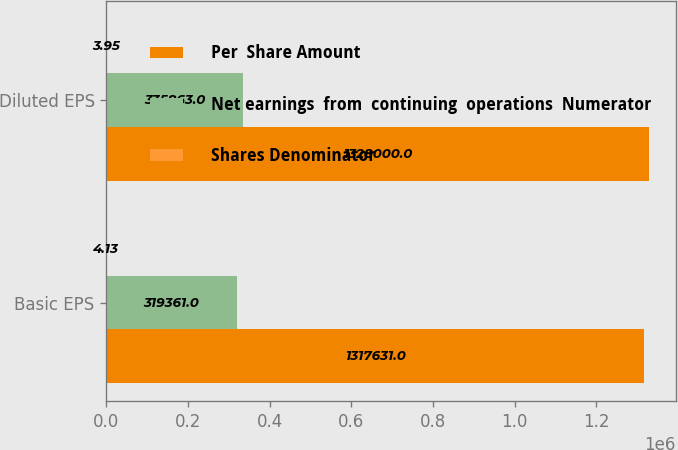<chart> <loc_0><loc_0><loc_500><loc_500><stacked_bar_chart><ecel><fcel>Basic EPS<fcel>Diluted EPS<nl><fcel>Per  Share Amount<fcel>1.31763e+06<fcel>1.328e+06<nl><fcel>Net earnings  from  continuing  operations  Numerator<fcel>319361<fcel>335863<nl><fcel>Shares Denominator<fcel>4.13<fcel>3.95<nl></chart> 